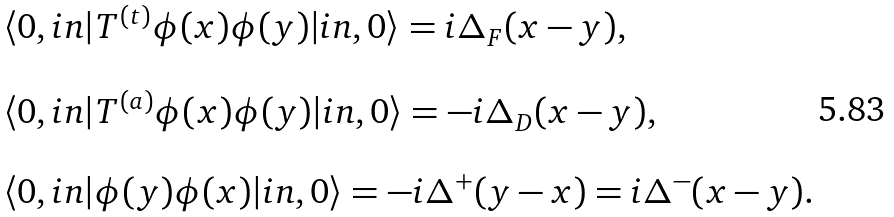<formula> <loc_0><loc_0><loc_500><loc_500>\begin{array} { l } \langle 0 , i n | T ^ { ( t ) } \phi ( x ) \phi ( y ) | i n , 0 \rangle = i \Delta _ { F } ( x - y ) , \\ \\ \langle 0 , i n | T ^ { ( a ) } \phi ( x ) \phi ( y ) | i n , 0 \rangle = - i \Delta _ { D } ( x - y ) , \\ \\ \langle 0 , i n | \phi ( y ) \phi ( x ) | i n , 0 \rangle = - i \Delta ^ { + } ( y - x ) = i \Delta ^ { - } ( x - y ) . \end{array}</formula> 